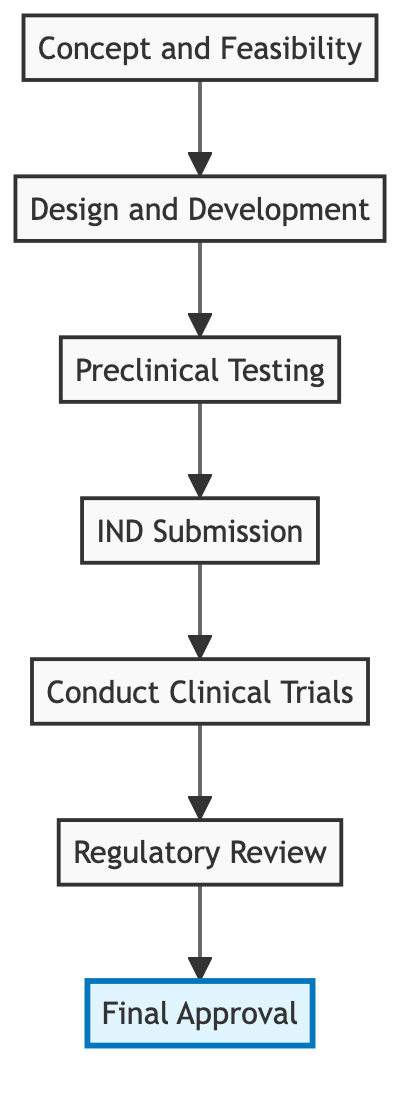What is the first step in the approval process? The diagram indicates the first step is "Concept and Feasibility," which is the starting point of the flow for developing a medical device.
Answer: Concept and Feasibility How many nodes are in the diagram? Counting the nodes in the diagram, there are seven distinct elements detailing each step in the approval process.
Answer: 7 What stage comes after "Preclinical Testing"? According to the flowchart, "IND Submission" is the next step that follows "Preclinical Testing," indicating the progression in the approval process.
Answer: IND Submission Which node is highlighted in the diagram? The highlighted node in the diagram is "Final Approval," indicating its significance as the endpoint of the approval process.
Answer: Final Approval What relationship is there between "Clinical Trials" and "Regulatory Review"? The flow illustrates that "Clinical Trials" leads directly to "Regulatory Review," showing that successful trials are followed by a regulatory assessment.
Answer: Clinical Trials leads to Regulatory Review What is the last step before final approval? The step preceding "Final Approval" is "Regulatory Review," which is necessary to ensure compliance before official approval.
Answer: Regulatory Review How many edges are there in the diagram? By following the connections between the nodes, there are six edges, representing the flow from one step to the next in the approval process.
Answer: 6 Which two nodes are adjacent to "IND Submission"? The nodes directly connected to "IND Submission" are "Preclinical Testing" and "Clinical Trials," indicating the steps that lead to and follow it.
Answer: Preclinical Testing, Clinical Trials What does the arrow from "Design and Development" indicate? The arrow from "Design and Development" to "Preclinical Testing" signifies that 'Design and Development' must be completed before testing can occur, indicating a sequential relationship.
Answer: Sequential relationship What represents the official confirmation in this process? "Final Approval" indicates the formal confirmation that a medical device is approved for market entry after complying with all regulations.
Answer: Final Approval 